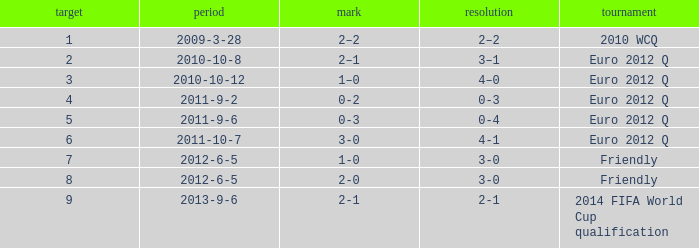How many goals when the score is 3-0 in the euro 2012 q? 1.0. Give me the full table as a dictionary. {'header': ['target', 'period', 'mark', 'resolution', 'tournament'], 'rows': [['1', '2009-3-28', '2–2', '2–2', '2010 WCQ'], ['2', '2010-10-8', '2–1', '3–1', 'Euro 2012 Q'], ['3', '2010-10-12', '1–0', '4–0', 'Euro 2012 Q'], ['4', '2011-9-2', '0-2', '0-3', 'Euro 2012 Q'], ['5', '2011-9-6', '0-3', '0-4', 'Euro 2012 Q'], ['6', '2011-10-7', '3-0', '4-1', 'Euro 2012 Q'], ['7', '2012-6-5', '1-0', '3-0', 'Friendly'], ['8', '2012-6-5', '2-0', '3-0', 'Friendly'], ['9', '2013-9-6', '2-1', '2-1', '2014 FIFA World Cup qualification']]} 